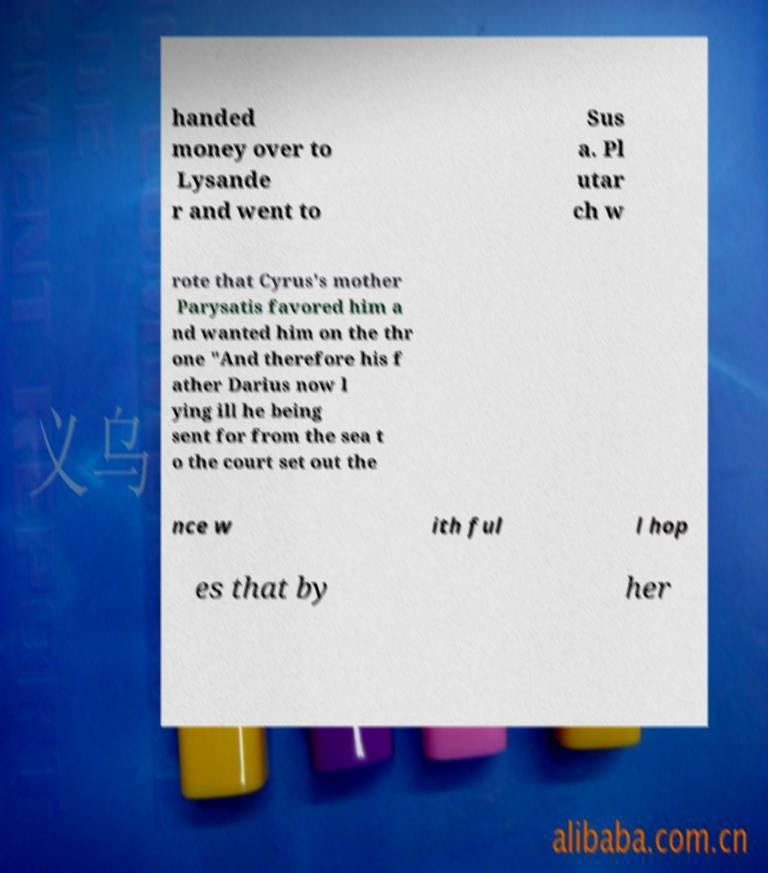Could you extract and type out the text from this image? handed money over to Lysande r and went to Sus a. Pl utar ch w rote that Cyrus's mother Parysatis favored him a nd wanted him on the thr one "And therefore his f ather Darius now l ying ill he being sent for from the sea t o the court set out the nce w ith ful l hop es that by her 